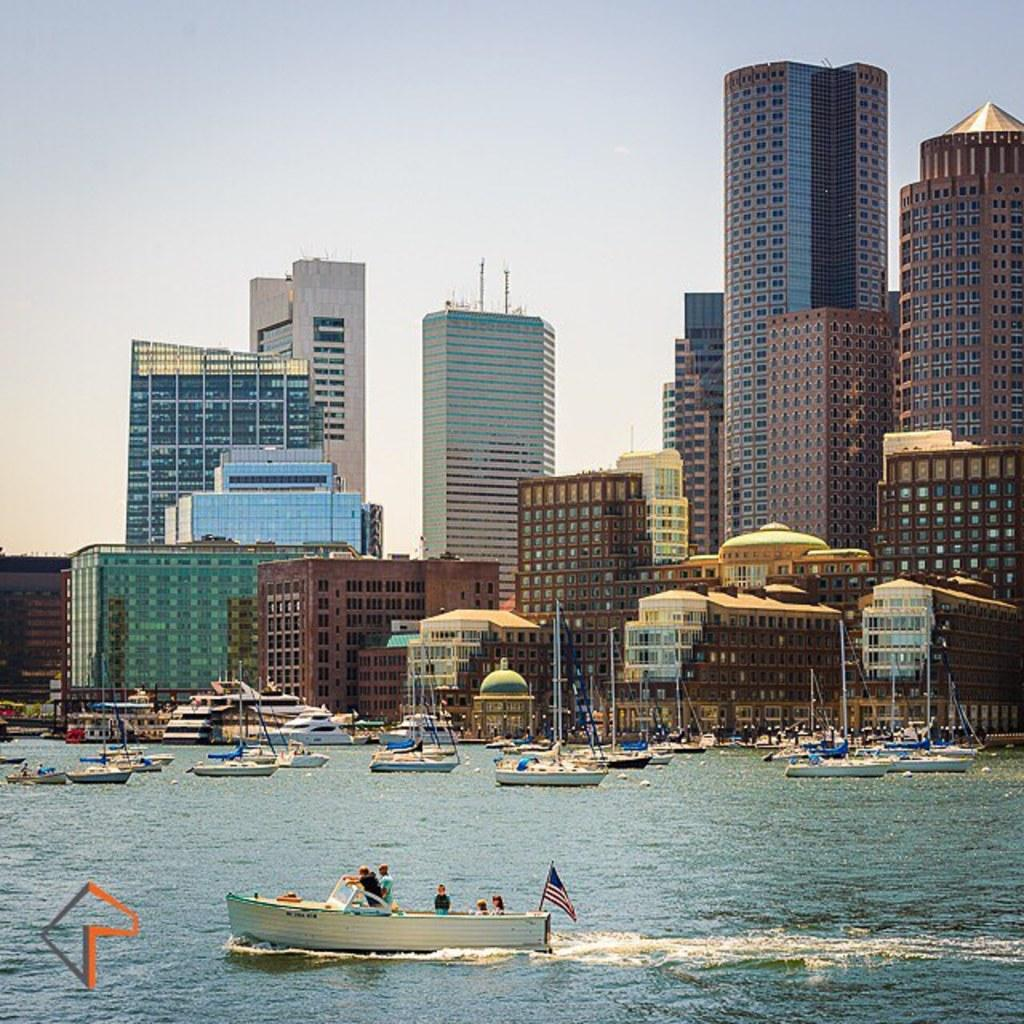What is the primary element visible in the image? There is water in the image. What else can be seen in the water? There are boats in the image. What structures are visible in the background? There are buildings in the image. What is visible at the top of the image? The sky is visible at the top of the image. What type of iron is being used to promote growth in the image? There is no iron or growth promotion visible in the image; it features water, boats, buildings, and the sky. 